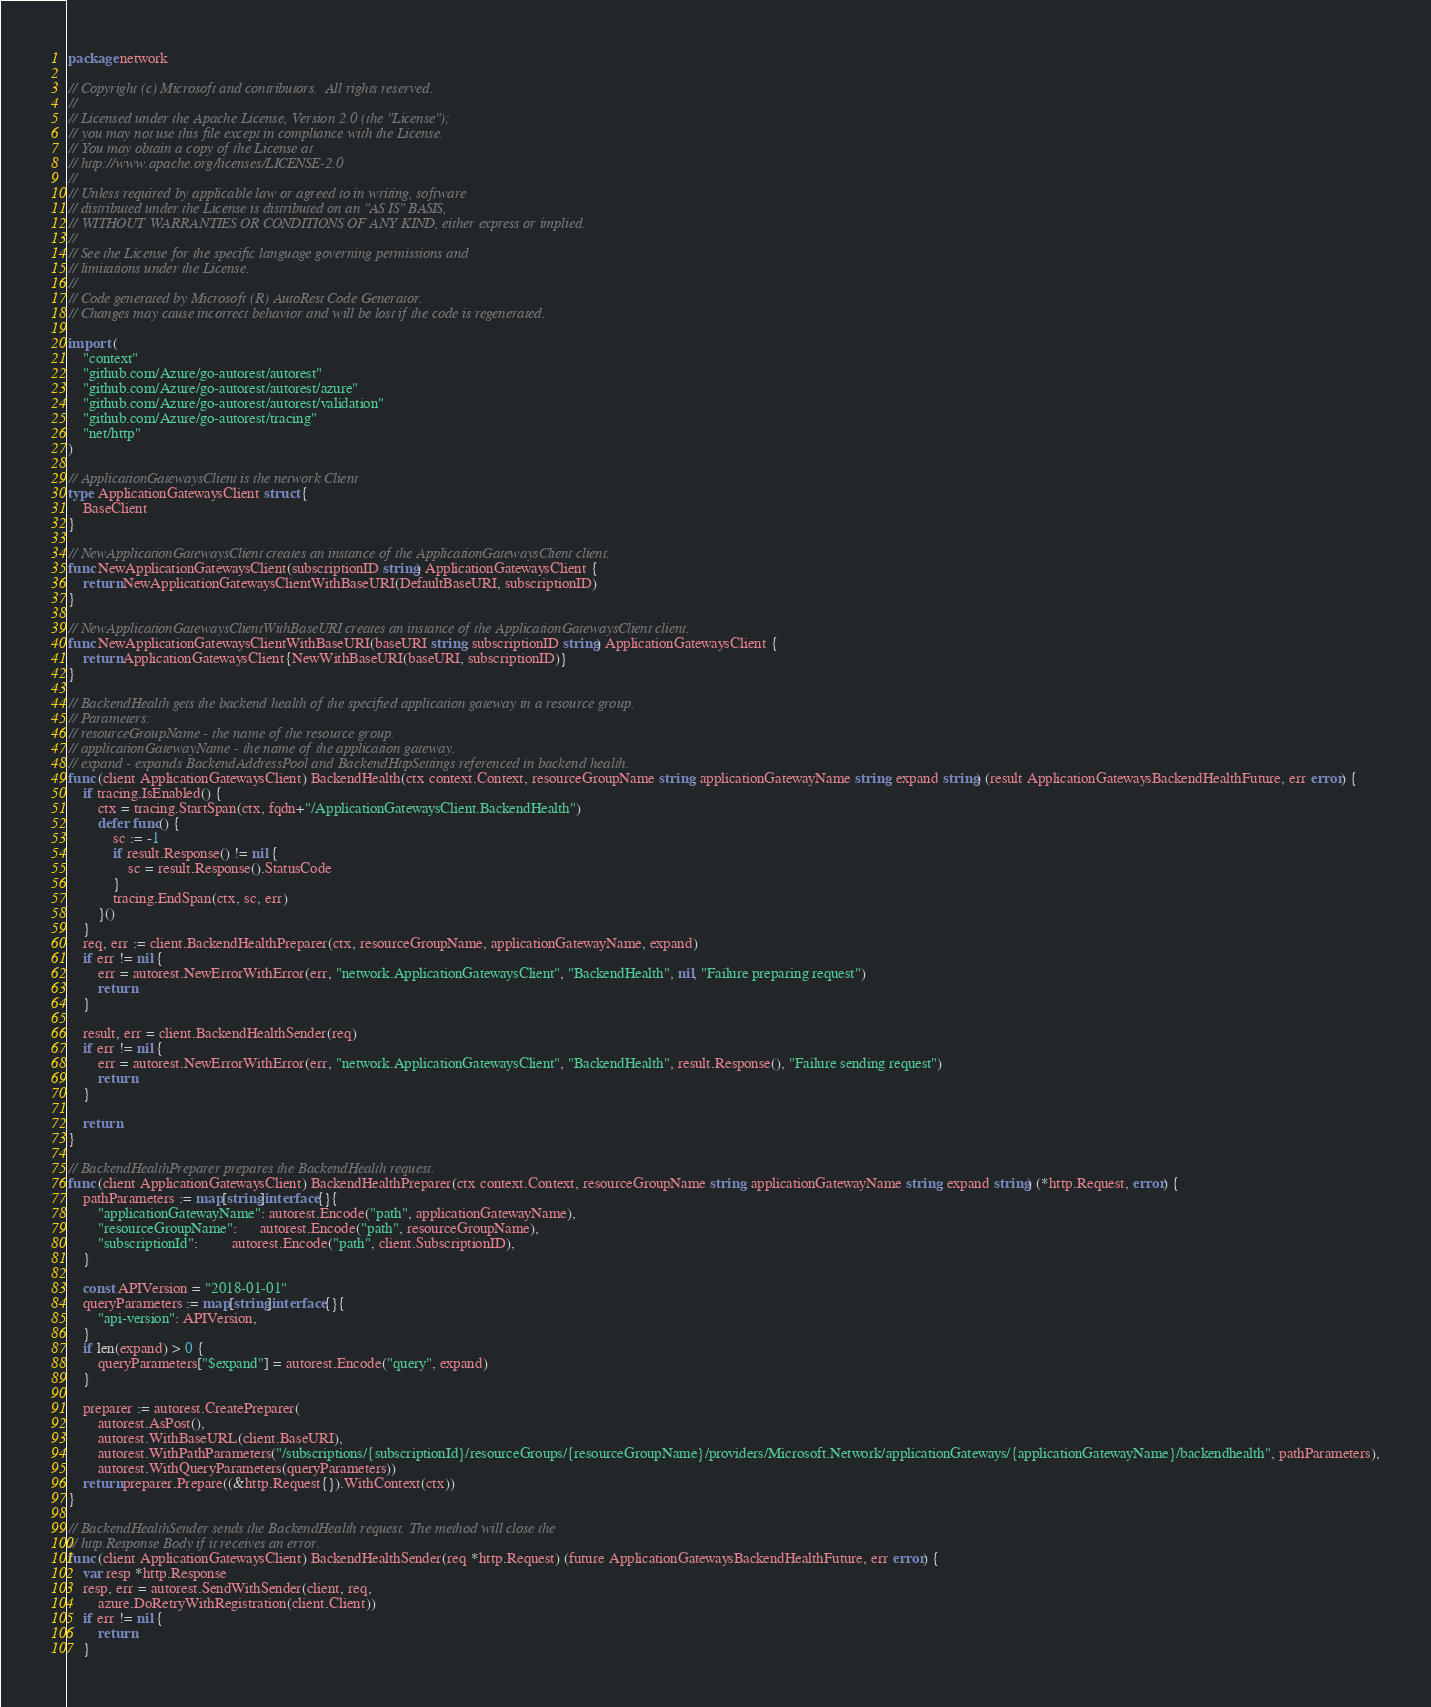Convert code to text. <code><loc_0><loc_0><loc_500><loc_500><_Go_>package network

// Copyright (c) Microsoft and contributors.  All rights reserved.
//
// Licensed under the Apache License, Version 2.0 (the "License");
// you may not use this file except in compliance with the License.
// You may obtain a copy of the License at
// http://www.apache.org/licenses/LICENSE-2.0
//
// Unless required by applicable law or agreed to in writing, software
// distributed under the License is distributed on an "AS IS" BASIS,
// WITHOUT WARRANTIES OR CONDITIONS OF ANY KIND, either express or implied.
//
// See the License for the specific language governing permissions and
// limitations under the License.
//
// Code generated by Microsoft (R) AutoRest Code Generator.
// Changes may cause incorrect behavior and will be lost if the code is regenerated.

import (
	"context"
	"github.com/Azure/go-autorest/autorest"
	"github.com/Azure/go-autorest/autorest/azure"
	"github.com/Azure/go-autorest/autorest/validation"
	"github.com/Azure/go-autorest/tracing"
	"net/http"
)

// ApplicationGatewaysClient is the network Client
type ApplicationGatewaysClient struct {
	BaseClient
}

// NewApplicationGatewaysClient creates an instance of the ApplicationGatewaysClient client.
func NewApplicationGatewaysClient(subscriptionID string) ApplicationGatewaysClient {
	return NewApplicationGatewaysClientWithBaseURI(DefaultBaseURI, subscriptionID)
}

// NewApplicationGatewaysClientWithBaseURI creates an instance of the ApplicationGatewaysClient client.
func NewApplicationGatewaysClientWithBaseURI(baseURI string, subscriptionID string) ApplicationGatewaysClient {
	return ApplicationGatewaysClient{NewWithBaseURI(baseURI, subscriptionID)}
}

// BackendHealth gets the backend health of the specified application gateway in a resource group.
// Parameters:
// resourceGroupName - the name of the resource group.
// applicationGatewayName - the name of the application gateway.
// expand - expands BackendAddressPool and BackendHttpSettings referenced in backend health.
func (client ApplicationGatewaysClient) BackendHealth(ctx context.Context, resourceGroupName string, applicationGatewayName string, expand string) (result ApplicationGatewaysBackendHealthFuture, err error) {
	if tracing.IsEnabled() {
		ctx = tracing.StartSpan(ctx, fqdn+"/ApplicationGatewaysClient.BackendHealth")
		defer func() {
			sc := -1
			if result.Response() != nil {
				sc = result.Response().StatusCode
			}
			tracing.EndSpan(ctx, sc, err)
		}()
	}
	req, err := client.BackendHealthPreparer(ctx, resourceGroupName, applicationGatewayName, expand)
	if err != nil {
		err = autorest.NewErrorWithError(err, "network.ApplicationGatewaysClient", "BackendHealth", nil, "Failure preparing request")
		return
	}

	result, err = client.BackendHealthSender(req)
	if err != nil {
		err = autorest.NewErrorWithError(err, "network.ApplicationGatewaysClient", "BackendHealth", result.Response(), "Failure sending request")
		return
	}

	return
}

// BackendHealthPreparer prepares the BackendHealth request.
func (client ApplicationGatewaysClient) BackendHealthPreparer(ctx context.Context, resourceGroupName string, applicationGatewayName string, expand string) (*http.Request, error) {
	pathParameters := map[string]interface{}{
		"applicationGatewayName": autorest.Encode("path", applicationGatewayName),
		"resourceGroupName":      autorest.Encode("path", resourceGroupName),
		"subscriptionId":         autorest.Encode("path", client.SubscriptionID),
	}

	const APIVersion = "2018-01-01"
	queryParameters := map[string]interface{}{
		"api-version": APIVersion,
	}
	if len(expand) > 0 {
		queryParameters["$expand"] = autorest.Encode("query", expand)
	}

	preparer := autorest.CreatePreparer(
		autorest.AsPost(),
		autorest.WithBaseURL(client.BaseURI),
		autorest.WithPathParameters("/subscriptions/{subscriptionId}/resourceGroups/{resourceGroupName}/providers/Microsoft.Network/applicationGateways/{applicationGatewayName}/backendhealth", pathParameters),
		autorest.WithQueryParameters(queryParameters))
	return preparer.Prepare((&http.Request{}).WithContext(ctx))
}

// BackendHealthSender sends the BackendHealth request. The method will close the
// http.Response Body if it receives an error.
func (client ApplicationGatewaysClient) BackendHealthSender(req *http.Request) (future ApplicationGatewaysBackendHealthFuture, err error) {
	var resp *http.Response
	resp, err = autorest.SendWithSender(client, req,
		azure.DoRetryWithRegistration(client.Client))
	if err != nil {
		return
	}</code> 